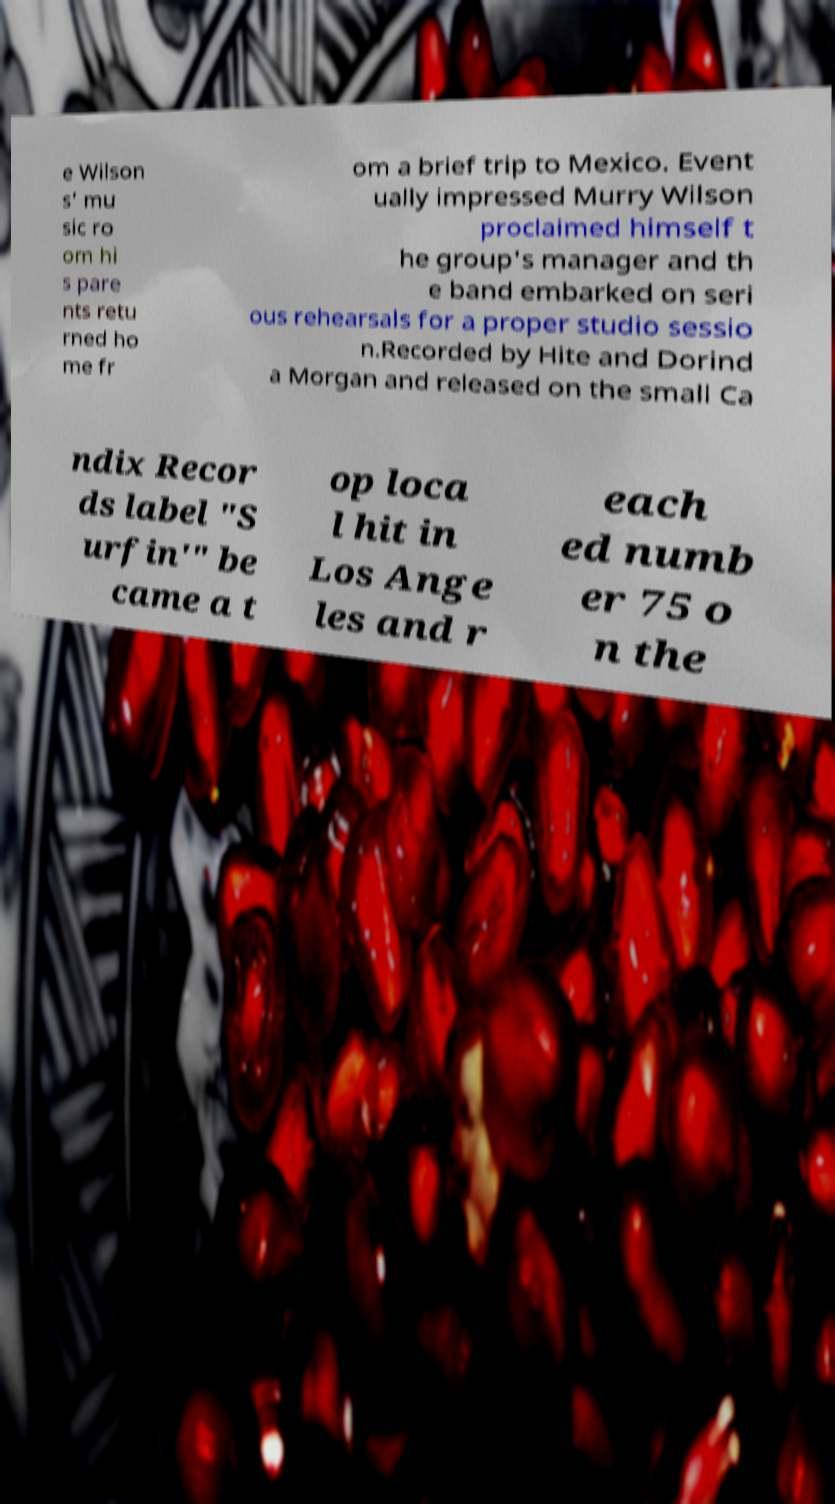Can you read and provide the text displayed in the image?This photo seems to have some interesting text. Can you extract and type it out for me? e Wilson s' mu sic ro om hi s pare nts retu rned ho me fr om a brief trip to Mexico. Event ually impressed Murry Wilson proclaimed himself t he group's manager and th e band embarked on seri ous rehearsals for a proper studio sessio n.Recorded by Hite and Dorind a Morgan and released on the small Ca ndix Recor ds label "S urfin'" be came a t op loca l hit in Los Ange les and r each ed numb er 75 o n the 